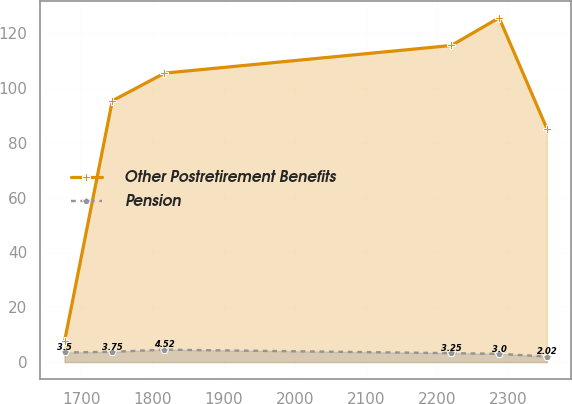Convert chart. <chart><loc_0><loc_0><loc_500><loc_500><line_chart><ecel><fcel>Other Postretirement Benefits<fcel>Pension<nl><fcel>1676.47<fcel>7.58<fcel>3.5<nl><fcel>1743.59<fcel>95.37<fcel>3.75<nl><fcel>1816.91<fcel>105.48<fcel>4.52<nl><fcel>2220.35<fcel>115.59<fcel>3.25<nl><fcel>2287.47<fcel>125.7<fcel>3<nl><fcel>2354.59<fcel>85.26<fcel>2.02<nl></chart> 